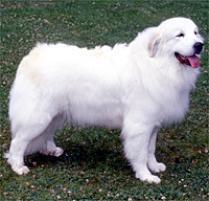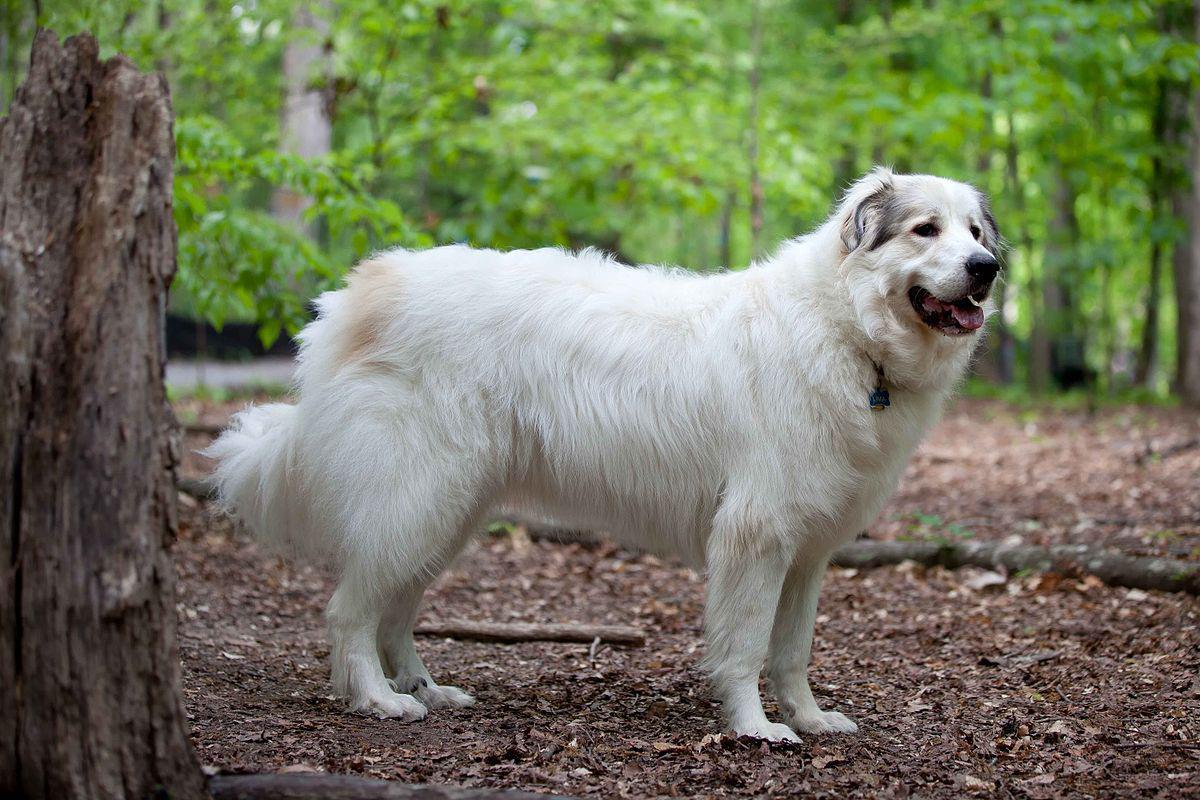The first image is the image on the left, the second image is the image on the right. For the images displayed, is the sentence "Each image contains a large white dog standing still with its body in profile, and the dogs in the images face the same direction." factually correct? Answer yes or no. Yes. The first image is the image on the left, the second image is the image on the right. Given the left and right images, does the statement "In at least one image, there is a white dog standing on grass facing left with a back of the sky." hold true? Answer yes or no. No. The first image is the image on the left, the second image is the image on the right. For the images displayed, is the sentence "Exactly two white dogs are on their feet, facing the same direction in an outdoor setting, one of them wearing a collar, both of them open mouthed with tongues showing." factually correct? Answer yes or no. Yes. The first image is the image on the left, the second image is the image on the right. Assess this claim about the two images: "All images show one dog that is standing.". Correct or not? Answer yes or no. Yes. The first image is the image on the left, the second image is the image on the right. Examine the images to the left and right. Is the description "There are at least 2 dogs facing left." accurate? Answer yes or no. No. The first image is the image on the left, the second image is the image on the right. Assess this claim about the two images: "All images show one adult dog standing still outdoors.". Correct or not? Answer yes or no. Yes. 